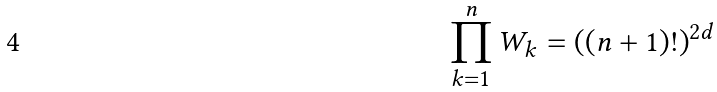Convert formula to latex. <formula><loc_0><loc_0><loc_500><loc_500>\prod _ { k = 1 } ^ { n } { W _ { k } } = ( ( n + 1 ) ! ) ^ { 2 d }</formula> 